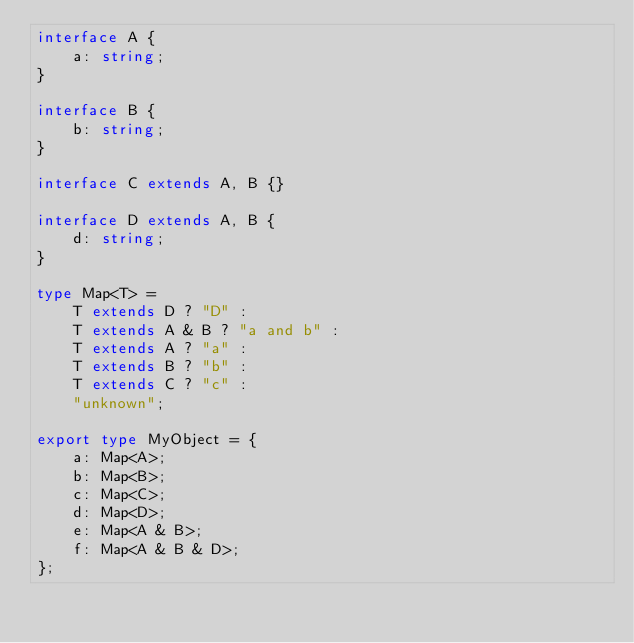<code> <loc_0><loc_0><loc_500><loc_500><_TypeScript_>interface A {
    a: string;
}

interface B {
    b: string;
}

interface C extends A, B {}

interface D extends A, B {
    d: string;
}

type Map<T> =
    T extends D ? "D" :
    T extends A & B ? "a and b" :
    T extends A ? "a" :
    T extends B ? "b" :
    T extends C ? "c" :
    "unknown";

export type MyObject = {
    a: Map<A>;
    b: Map<B>;
    c: Map<C>;
    d: Map<D>;
    e: Map<A & B>;
    f: Map<A & B & D>;
};
</code> 